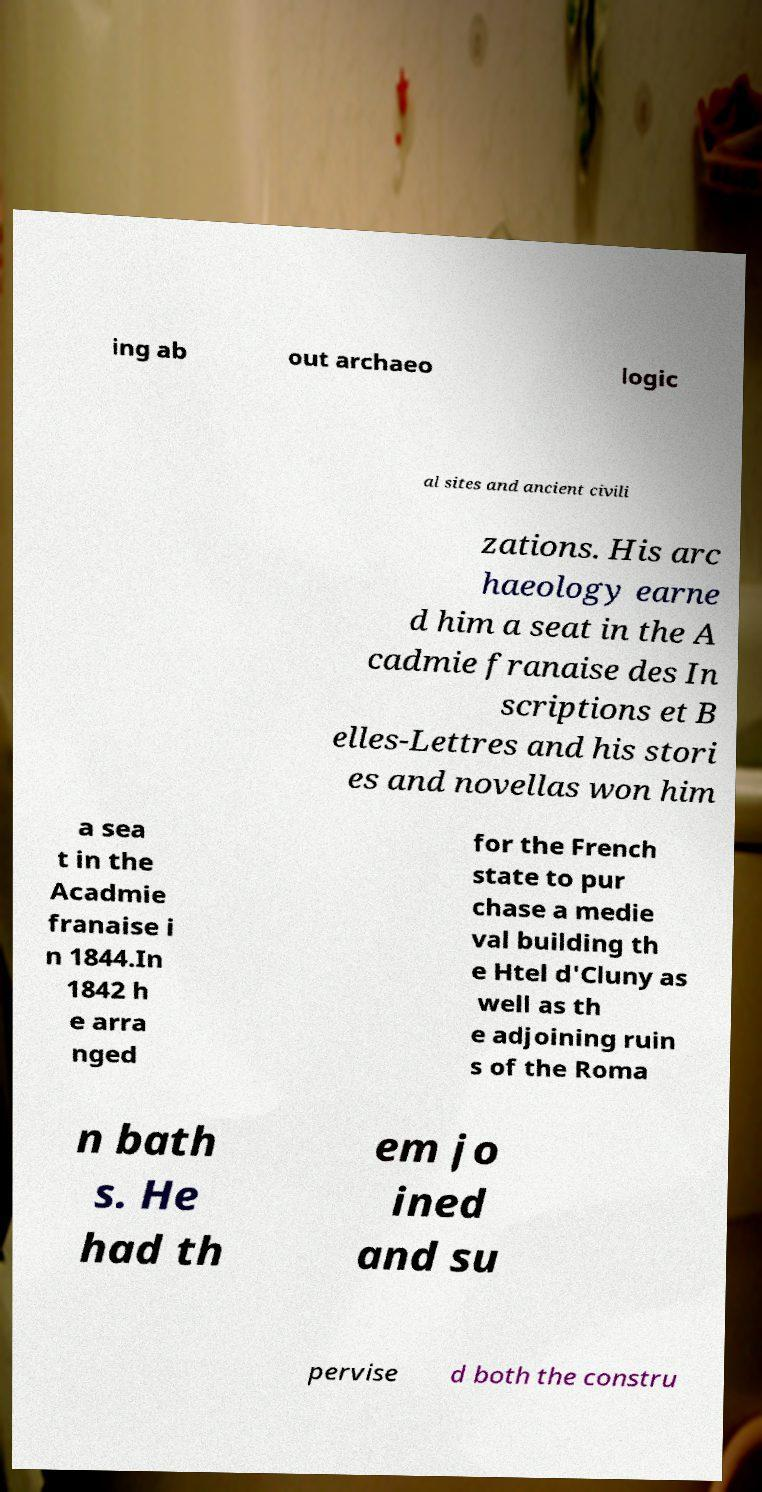Could you extract and type out the text from this image? ing ab out archaeo logic al sites and ancient civili zations. His arc haeology earne d him a seat in the A cadmie franaise des In scriptions et B elles-Lettres and his stori es and novellas won him a sea t in the Acadmie franaise i n 1844.In 1842 h e arra nged for the French state to pur chase a medie val building th e Htel d'Cluny as well as th e adjoining ruin s of the Roma n bath s. He had th em jo ined and su pervise d both the constru 